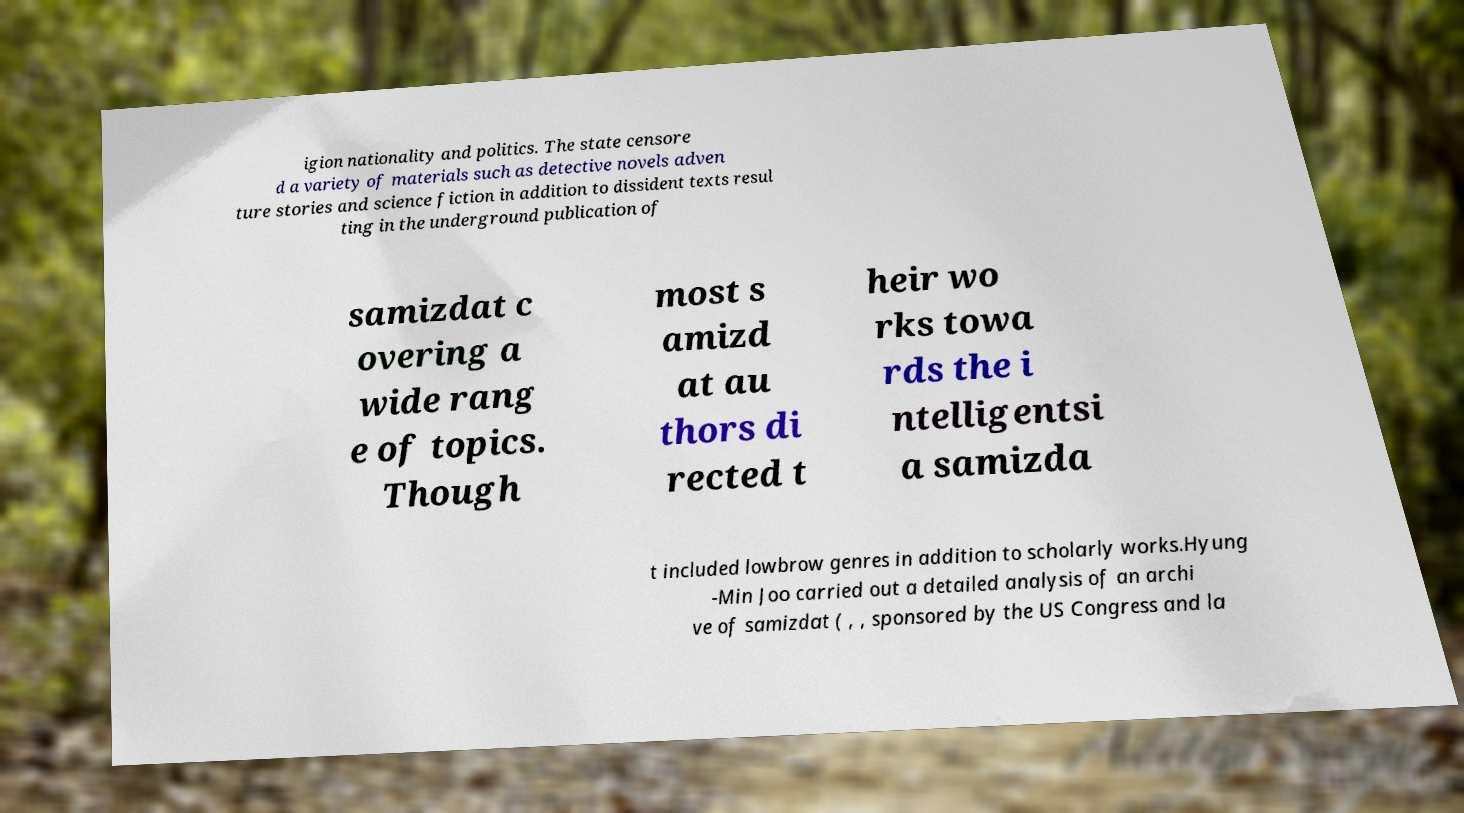What messages or text are displayed in this image? I need them in a readable, typed format. igion nationality and politics. The state censore d a variety of materials such as detective novels adven ture stories and science fiction in addition to dissident texts resul ting in the underground publication of samizdat c overing a wide rang e of topics. Though most s amizd at au thors di rected t heir wo rks towa rds the i ntelligentsi a samizda t included lowbrow genres in addition to scholarly works.Hyung -Min Joo carried out a detailed analysis of an archi ve of samizdat ( , , sponsored by the US Congress and la 